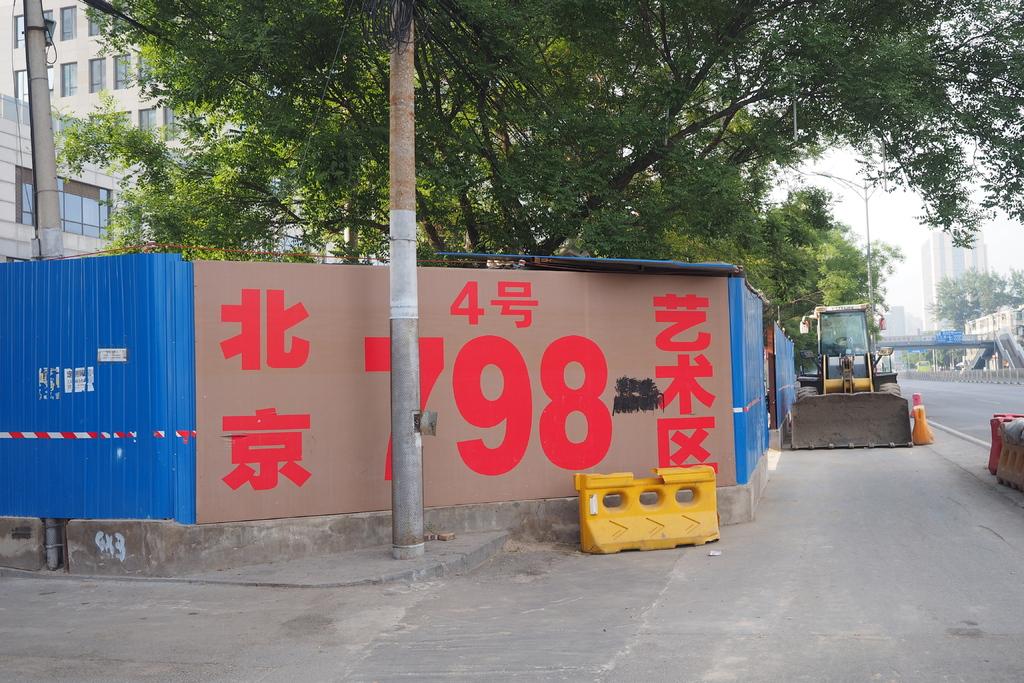What number is on the wall?
Offer a terse response. 798. Whats the color on the writing?
Offer a terse response. Red. 